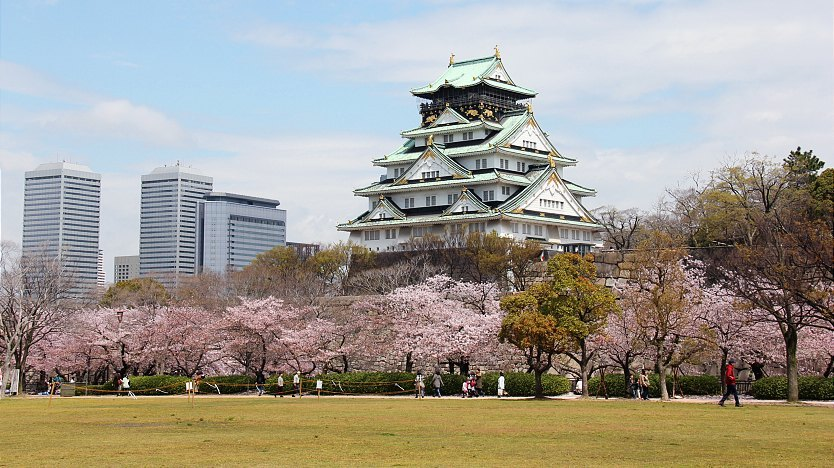What would it be like to visit Osaka Castle during the cherry blossom festival? Visiting Osaka Castle during the cherry blossom festival, known as 'Hanami', would be a surreal and enchanting experience. Visitors would be greeted by the sight of hundreds of cherry trees in full bloom, their branches heavy with delicate pink flowers. The air would be filled with the sweet scent of the blossoms and the joyful sounds of people celebrating this annual occasion. Families and friends would gather in the park around the castle, enjoying picnics under the sakura trees, sharing food and laughter. The castle itself, standing majestically amidst this sea of pink, provides a stunning backdrop for photographs and leisurely strolls. Traditional performances, music, and market stalls selling local delicacies and souvenirs would add to the festive atmosphere, making it a magical time to explore and appreciate the beauty and history of Osaka Castle. 